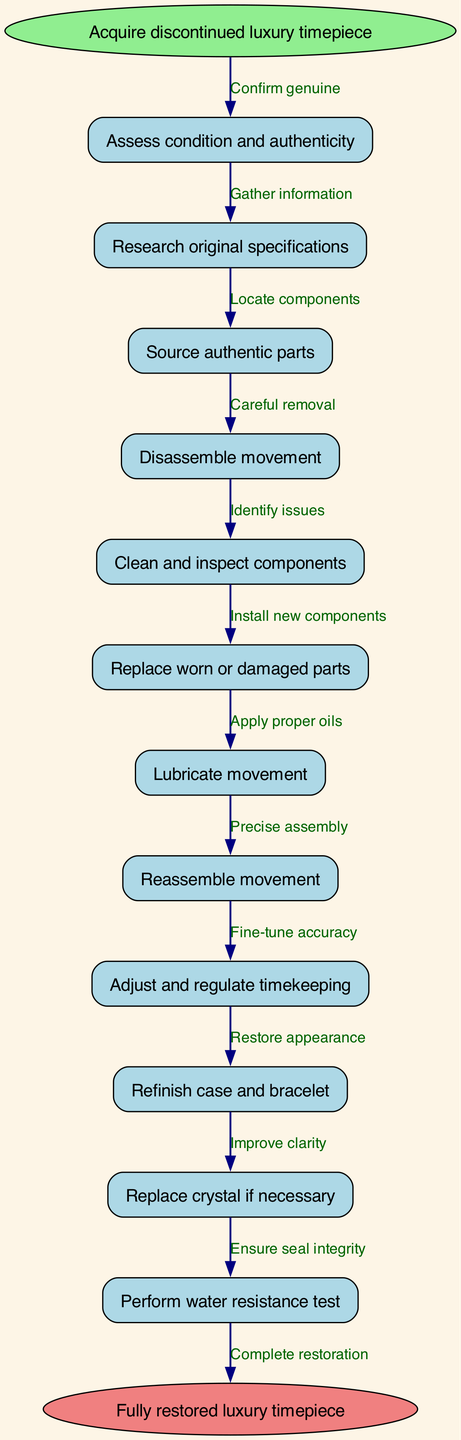What is the starting node of the diagram? The starting node is explicitly mentioned in the diagram as "Acquire discontinued luxury timepiece," which is where the process begins.
Answer: Acquire discontinued luxury timepiece How many steps are there in the restoration process? By counting each node in the steps array, there are 12 steps listed in the diagram outlining the restoration process.
Answer: 12 What is the last step before completion of the restoration process? The last step before reaching the end node is "Perform water resistance test," which indicates it's the final action taken before the timepiece is fully restored.
Answer: Perform water resistance test What node follows "Clean and inspect components"? The flow proceeds to "Replace worn or damaged parts," which is the next operation after the cleaning and inspection stage.
Answer: Replace worn or damaged parts What action is taken after replacing worn or damaged parts? Following the replacement of worn or damaged parts, the next action specified is "Lubricate movement," which is essential for optimal performance.
Answer: Lubricate movement What is the purpose of "Refinish case and bracelet"? This step aims to "Restore appearance," indicating that it focuses on improving the visual quality of the watch.
Answer: Restore appearance Which step involves ensuring the integrity of the watch’s seal? This is covered under "Perform water resistance test," which checks the watch's ability to withstand water intrusion.
Answer: Perform water resistance test In the process, what must be confirmed before moving to the next steps? The initial step requires confirming authenticity; only after that can the process continue with further detailed restoration actions.
Answer: Confirm genuine What does "Adjust and regulate timekeeping" aim to achieve? This step is intended to "Fine-tune accuracy," ensuring that the timepiece keeps correct time after restoration.
Answer: Fine-tune accuracy 